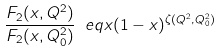<formula> <loc_0><loc_0><loc_500><loc_500>\frac { F _ { 2 } ( x , Q ^ { 2 } ) } { F _ { 2 } ( x , Q ^ { 2 } _ { 0 } ) } \ e q x ( 1 - x ) ^ { \zeta ( Q ^ { 2 } , Q ^ { 2 } _ { 0 } ) }</formula> 